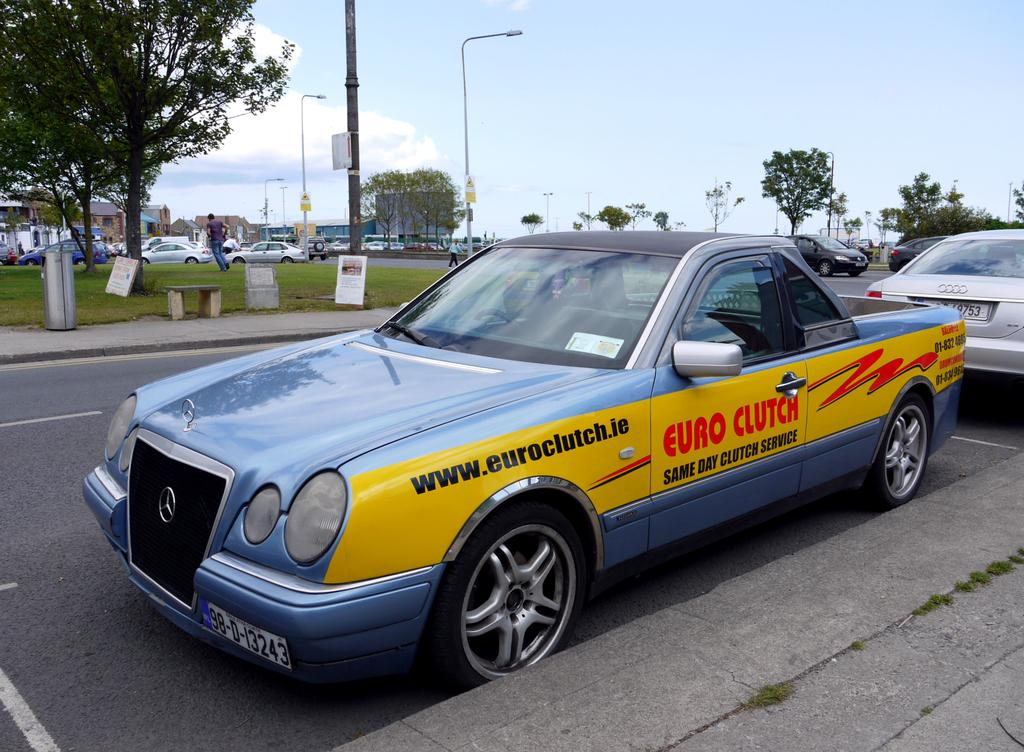<image>
Share a concise interpretation of the image provided. A pickup truck has the web address www.euroclutch.ie on the side. 